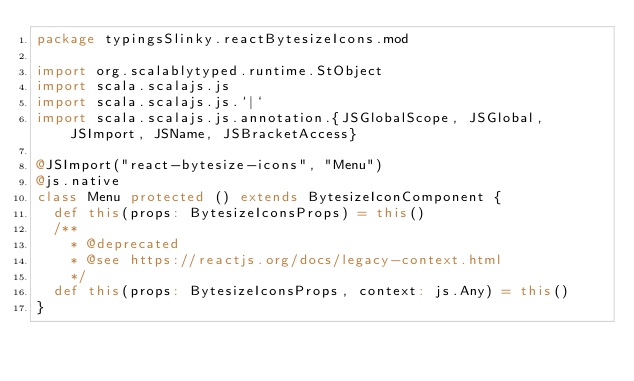Convert code to text. <code><loc_0><loc_0><loc_500><loc_500><_Scala_>package typingsSlinky.reactBytesizeIcons.mod

import org.scalablytyped.runtime.StObject
import scala.scalajs.js
import scala.scalajs.js.`|`
import scala.scalajs.js.annotation.{JSGlobalScope, JSGlobal, JSImport, JSName, JSBracketAccess}

@JSImport("react-bytesize-icons", "Menu")
@js.native
class Menu protected () extends BytesizeIconComponent {
  def this(props: BytesizeIconsProps) = this()
  /**
    * @deprecated
    * @see https://reactjs.org/docs/legacy-context.html
    */
  def this(props: BytesizeIconsProps, context: js.Any) = this()
}
</code> 